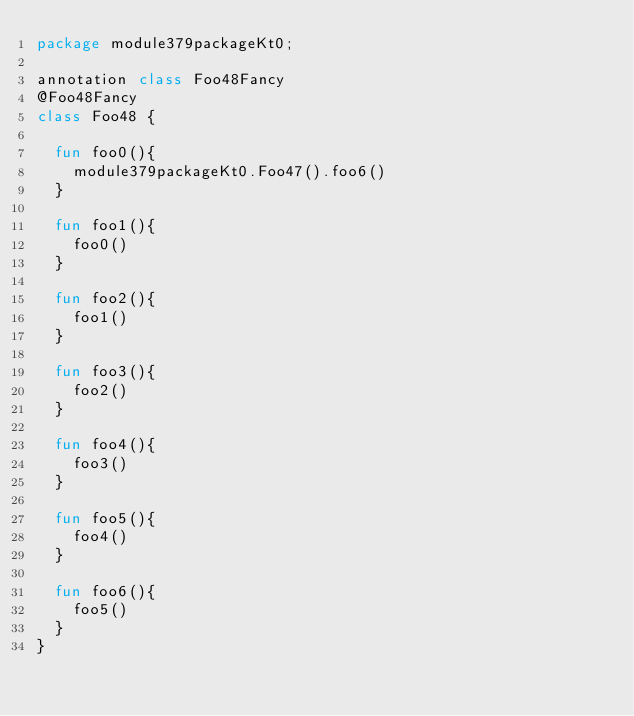<code> <loc_0><loc_0><loc_500><loc_500><_Kotlin_>package module379packageKt0;

annotation class Foo48Fancy
@Foo48Fancy
class Foo48 {

  fun foo0(){
    module379packageKt0.Foo47().foo6()
  }

  fun foo1(){
    foo0()
  }

  fun foo2(){
    foo1()
  }

  fun foo3(){
    foo2()
  }

  fun foo4(){
    foo3()
  }

  fun foo5(){
    foo4()
  }

  fun foo6(){
    foo5()
  }
}</code> 